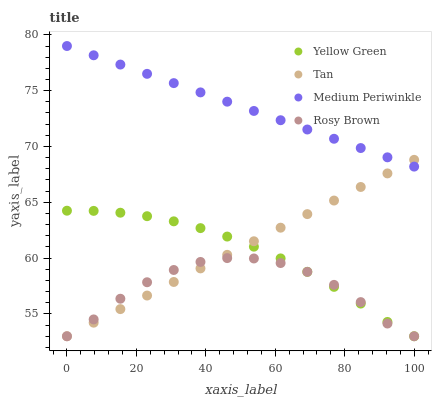Does Rosy Brown have the minimum area under the curve?
Answer yes or no. Yes. Does Medium Periwinkle have the maximum area under the curve?
Answer yes or no. Yes. Does Medium Periwinkle have the minimum area under the curve?
Answer yes or no. No. Does Rosy Brown have the maximum area under the curve?
Answer yes or no. No. Is Tan the smoothest?
Answer yes or no. Yes. Is Rosy Brown the roughest?
Answer yes or no. Yes. Is Medium Periwinkle the smoothest?
Answer yes or no. No. Is Medium Periwinkle the roughest?
Answer yes or no. No. Does Tan have the lowest value?
Answer yes or no. Yes. Does Medium Periwinkle have the lowest value?
Answer yes or no. No. Does Medium Periwinkle have the highest value?
Answer yes or no. Yes. Does Rosy Brown have the highest value?
Answer yes or no. No. Is Rosy Brown less than Medium Periwinkle?
Answer yes or no. Yes. Is Medium Periwinkle greater than Yellow Green?
Answer yes or no. Yes. Does Rosy Brown intersect Yellow Green?
Answer yes or no. Yes. Is Rosy Brown less than Yellow Green?
Answer yes or no. No. Is Rosy Brown greater than Yellow Green?
Answer yes or no. No. Does Rosy Brown intersect Medium Periwinkle?
Answer yes or no. No. 